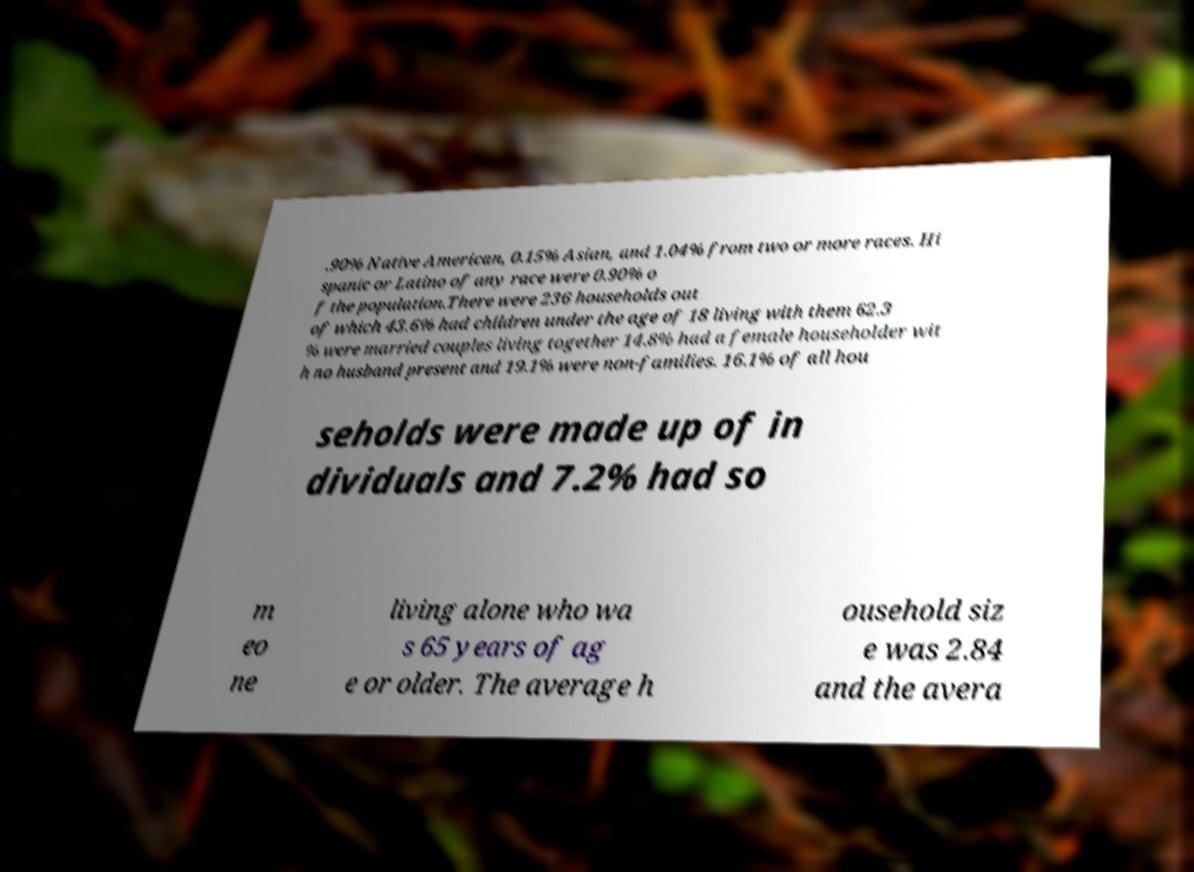Could you assist in decoding the text presented in this image and type it out clearly? .90% Native American, 0.15% Asian, and 1.04% from two or more races. Hi spanic or Latino of any race were 0.90% o f the population.There were 236 households out of which 43.6% had children under the age of 18 living with them 62.3 % were married couples living together 14.8% had a female householder wit h no husband present and 19.1% were non-families. 16.1% of all hou seholds were made up of in dividuals and 7.2% had so m eo ne living alone who wa s 65 years of ag e or older. The average h ousehold siz e was 2.84 and the avera 